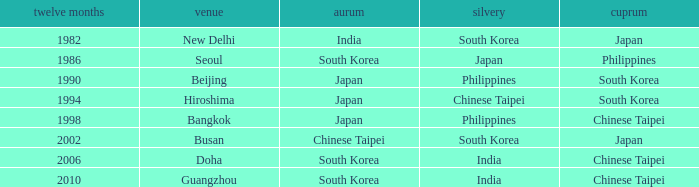How many years has Japan won silver? 1986.0. 